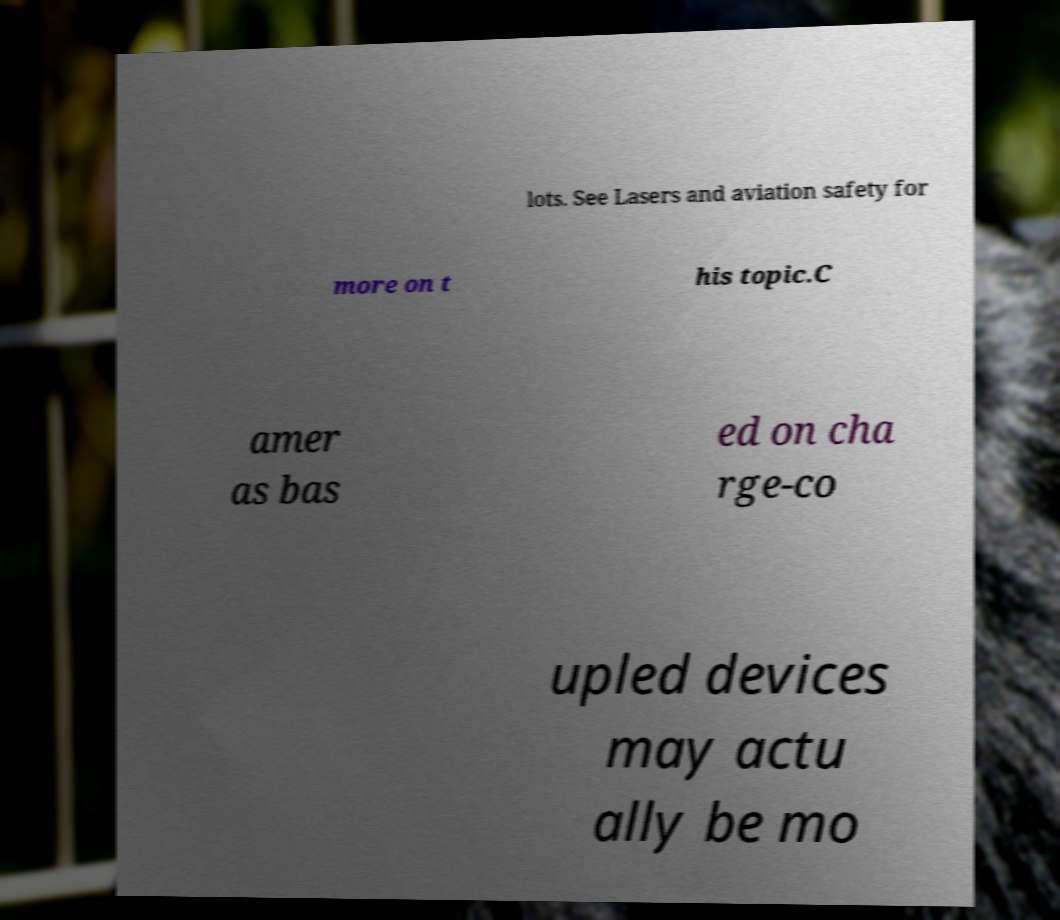What messages or text are displayed in this image? I need them in a readable, typed format. lots. See Lasers and aviation safety for more on t his topic.C amer as bas ed on cha rge-co upled devices may actu ally be mo 